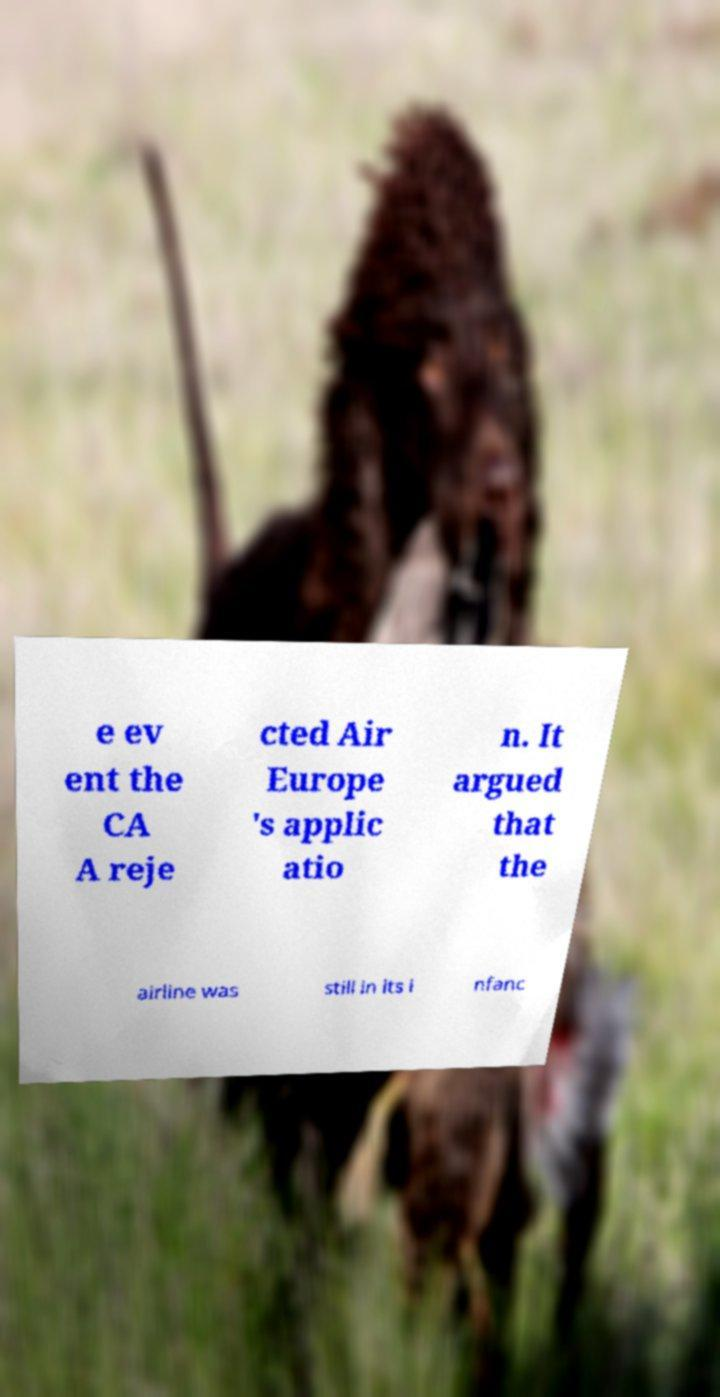Please read and relay the text visible in this image. What does it say? e ev ent the CA A reje cted Air Europe 's applic atio n. It argued that the airline was still in its i nfanc 